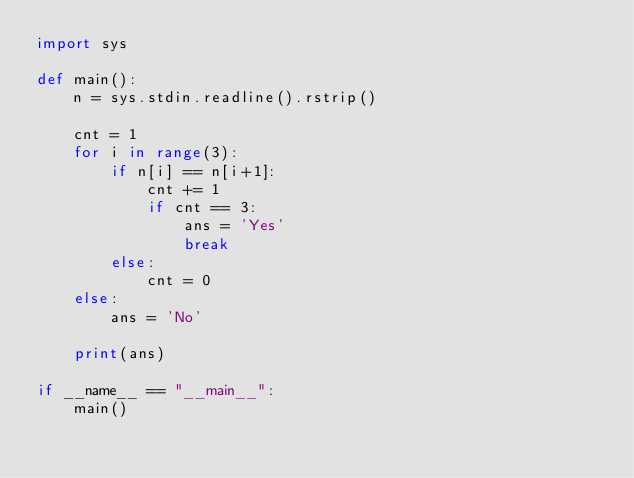Convert code to text. <code><loc_0><loc_0><loc_500><loc_500><_Python_>import sys

def main():
    n = sys.stdin.readline().rstrip()

    cnt = 1
    for i in range(3):
        if n[i] == n[i+1]:
            cnt += 1
            if cnt == 3:
                ans = 'Yes'
                break
        else:
            cnt = 0
    else:
        ans = 'No'
    
    print(ans)
    
if __name__ == "__main__":
    main()
</code> 